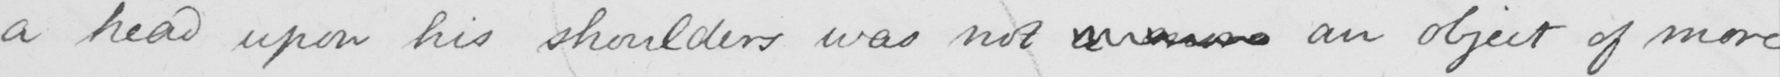Please transcribe the handwritten text in this image. a head upon his shoulders was not a more an object of more 